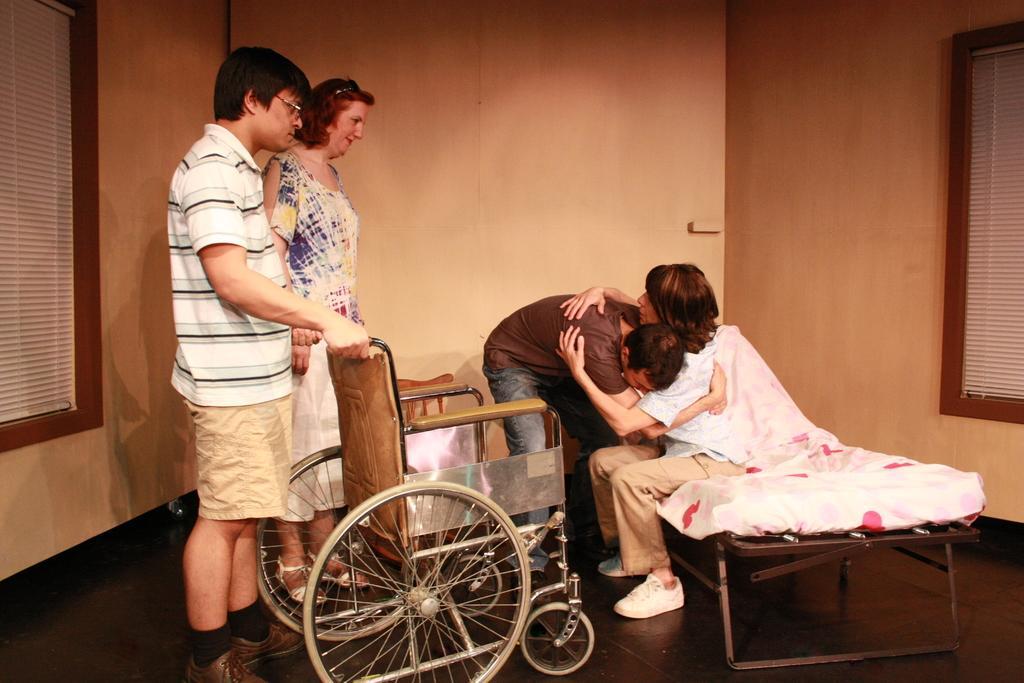Can you describe this image briefly? In this picture, we see the man is hugging the woman who is sitting on the bed. In front of her, we see a wheelchair. Beside that, we see two people are standing. On the left side, we see the window blind. On the right side, we see the window blind. In the background, we see a wall. 